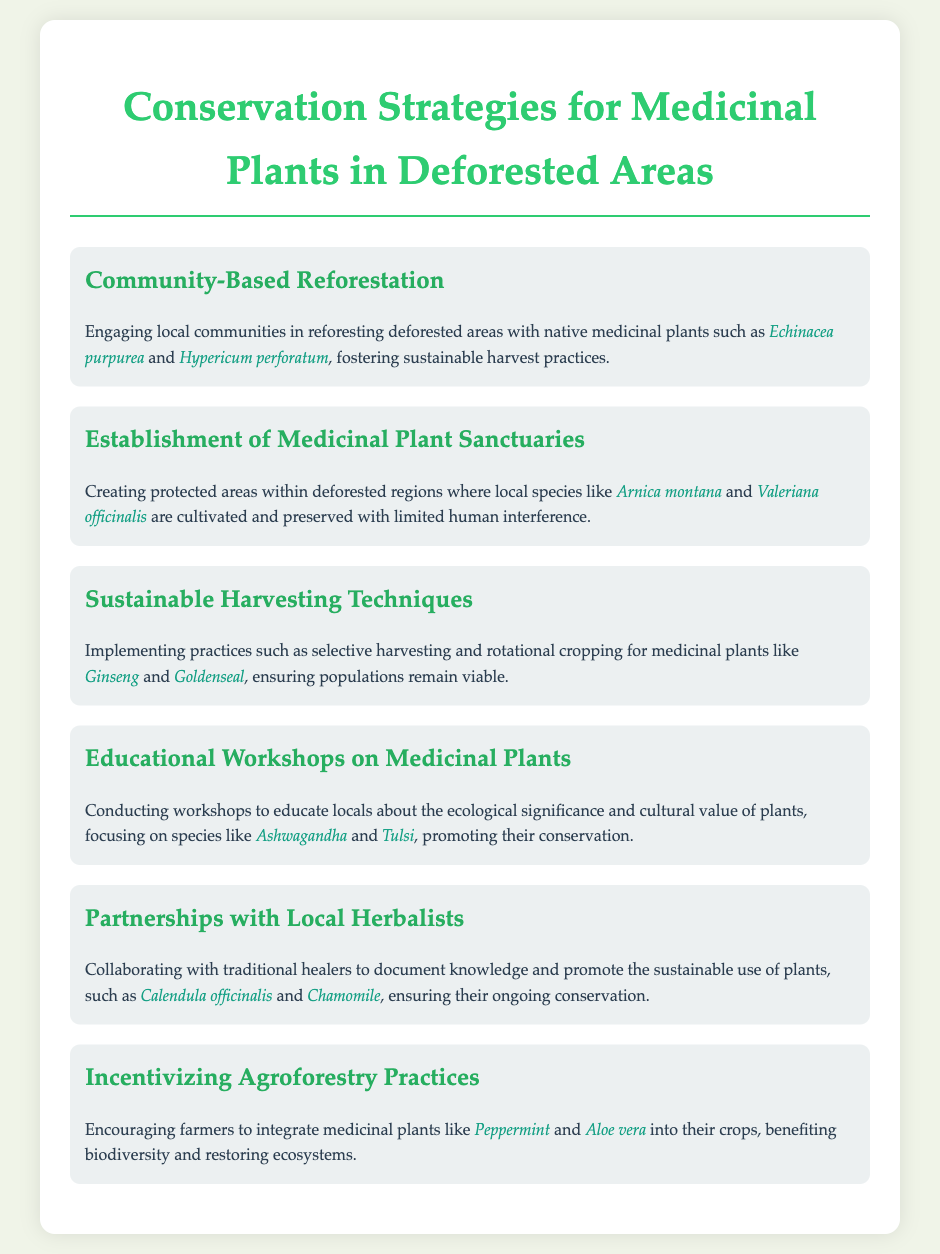What is the first conservation strategy mentioned? The first conservation strategy listed in the document is "Community-Based Reforestation."
Answer: Community-Based Reforestation Which medicinal plant is mentioned under the establishment of sanctuaries? The document lists "Arnica montana" as one of the species cultivated and preserved in medicinal plant sanctuaries.
Answer: Arnica montana What practice is suggested for sustainable harvesting? The document mentions "selective harvesting" as one of the practices for sustainable harvesting techniques.
Answer: Selective harvesting How many conservation strategies are presented in the document? The document outlines a total of six conservation strategies for medicinal plants in deforested areas.
Answer: Six What is the focus of the educational workshops? The educational workshops focus on the "ecological significance and cultural value" of medicinal plants.
Answer: Ecological significance and cultural value Which plant is suggested for incentivizing agroforestry practices? The document suggests "Peppermint" as a medicinal plant for agroforestry practices.
Answer: Peppermint Who should collaborations target according to the partnerships strategy? Collaborations should target "local herbalists" according to the partnerships strategy outlined in the document.
Answer: Local herbalists What is the intended outcome of creating medicinal plant sanctuaries? The intended outcome is to cultivate and preserve local species with "limited human interference."
Answer: Limited human interference 